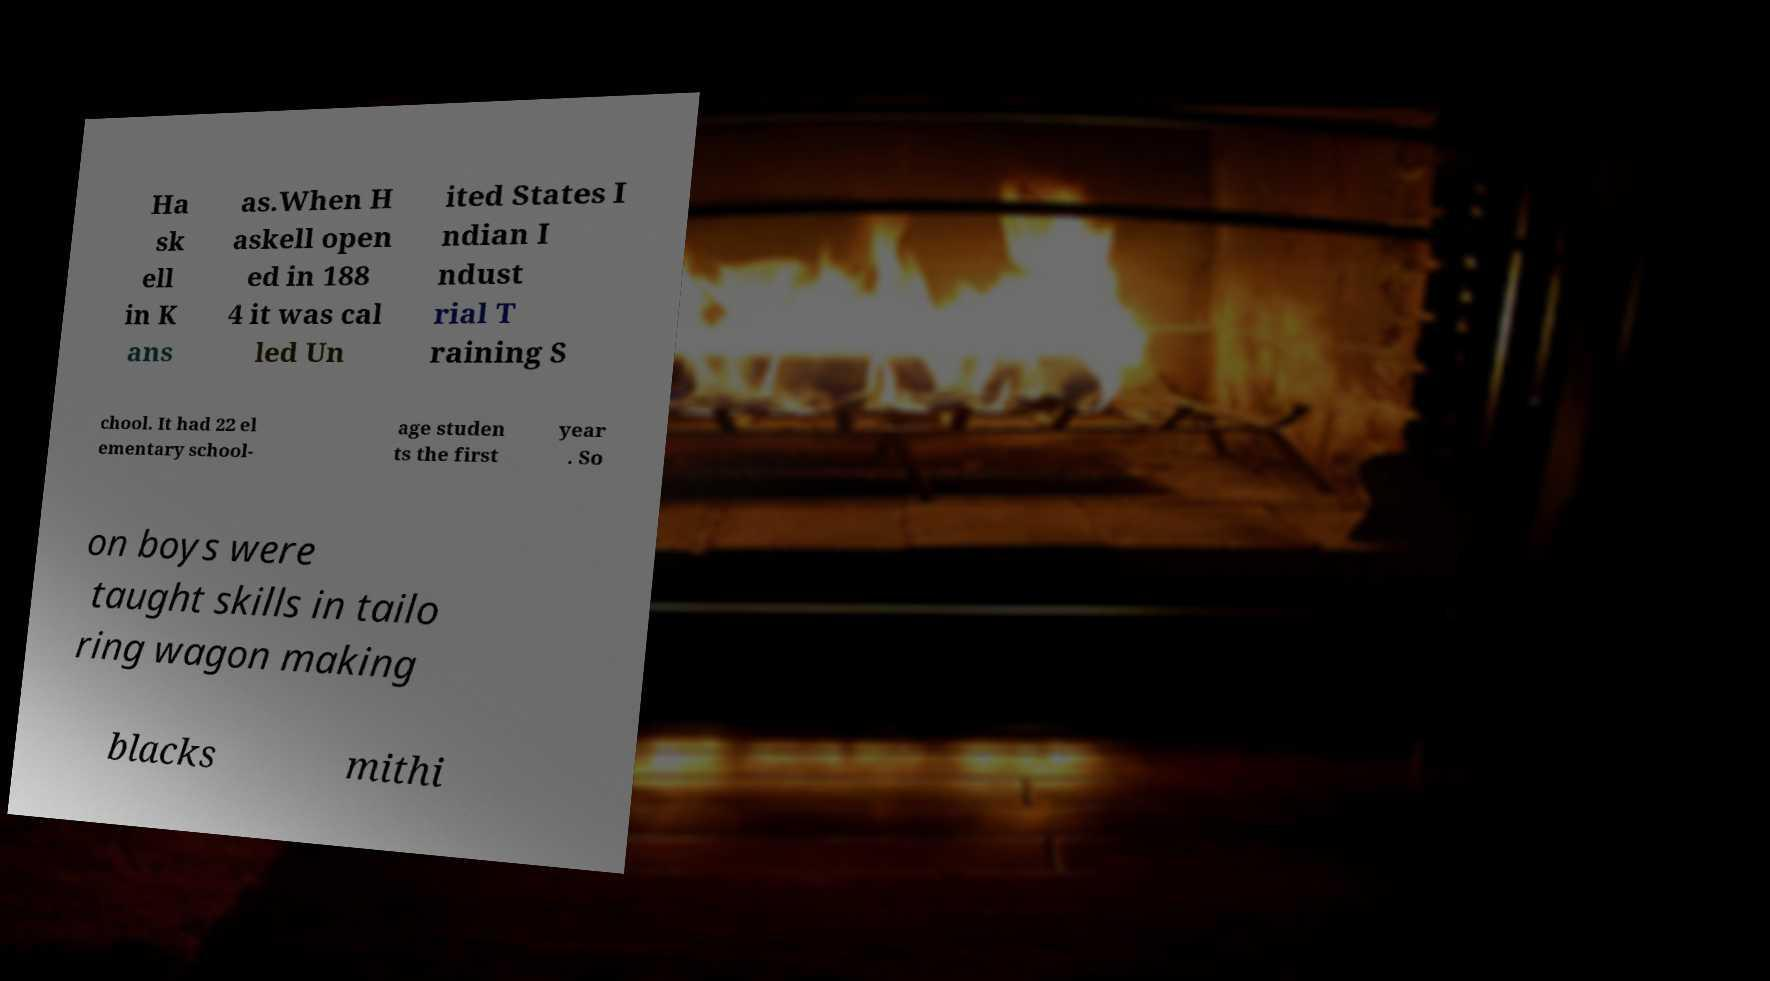Please identify and transcribe the text found in this image. Ha sk ell in K ans as.When H askell open ed in 188 4 it was cal led Un ited States I ndian I ndust rial T raining S chool. It had 22 el ementary school- age studen ts the first year . So on boys were taught skills in tailo ring wagon making blacks mithi 